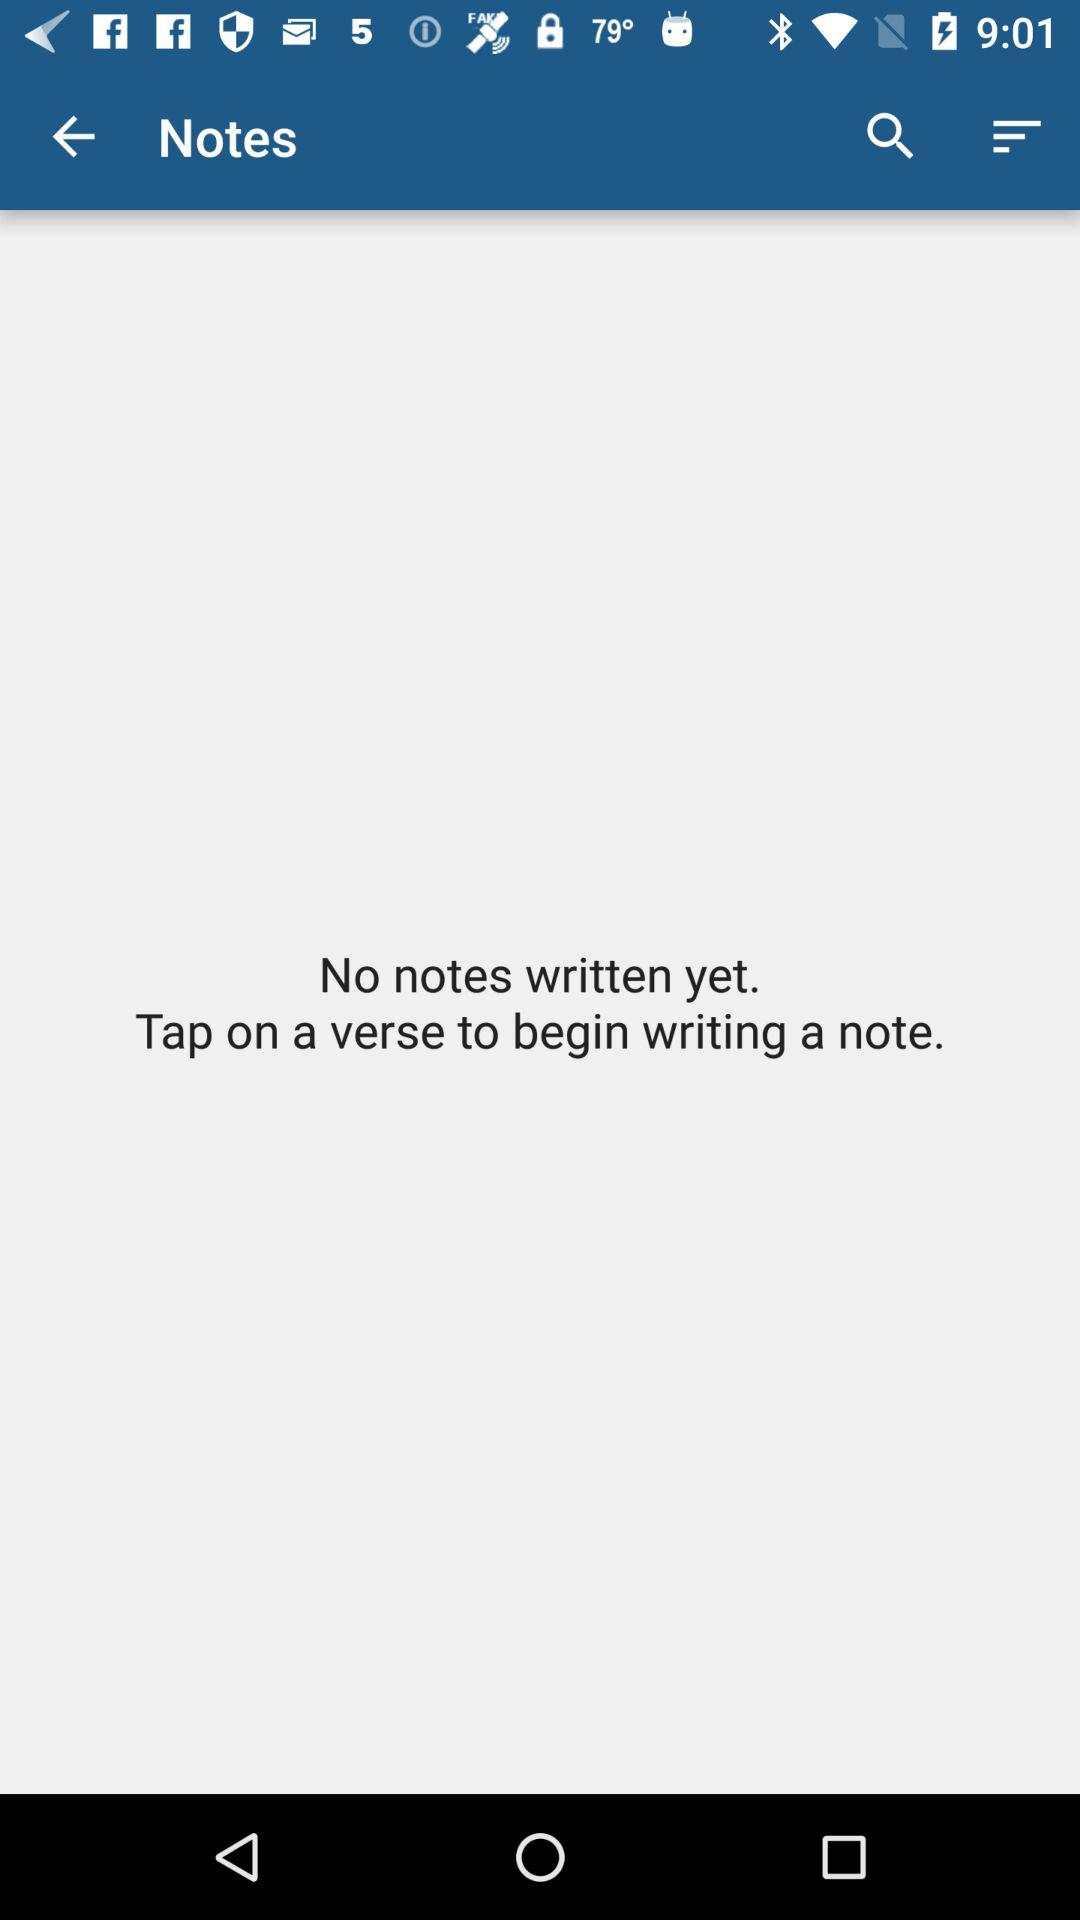How many notes are there?
Answer the question using a single word or phrase. 0 